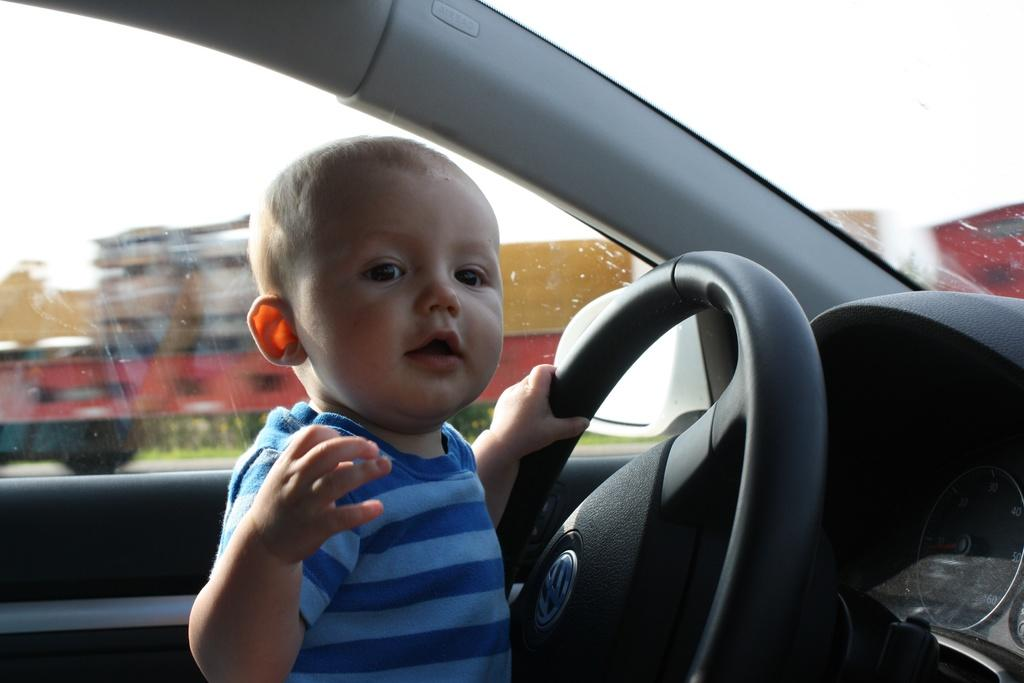What is the setting of the image? The image shows an inside view of a car. Who is present in the car? There is a small boy in the car. What is the boy doing in the image? The boy is smiling and holding a Volkswagen car steering. What can be seen outside the car through the window? There is a big truck visible through the glass window in the car. Where is the bucket used for waste disposal located in the image? There is no bucket or waste disposal present in the image. Is the boy playing baseball in the car? There is no indication of a baseball or any baseball-related activity in the image. 